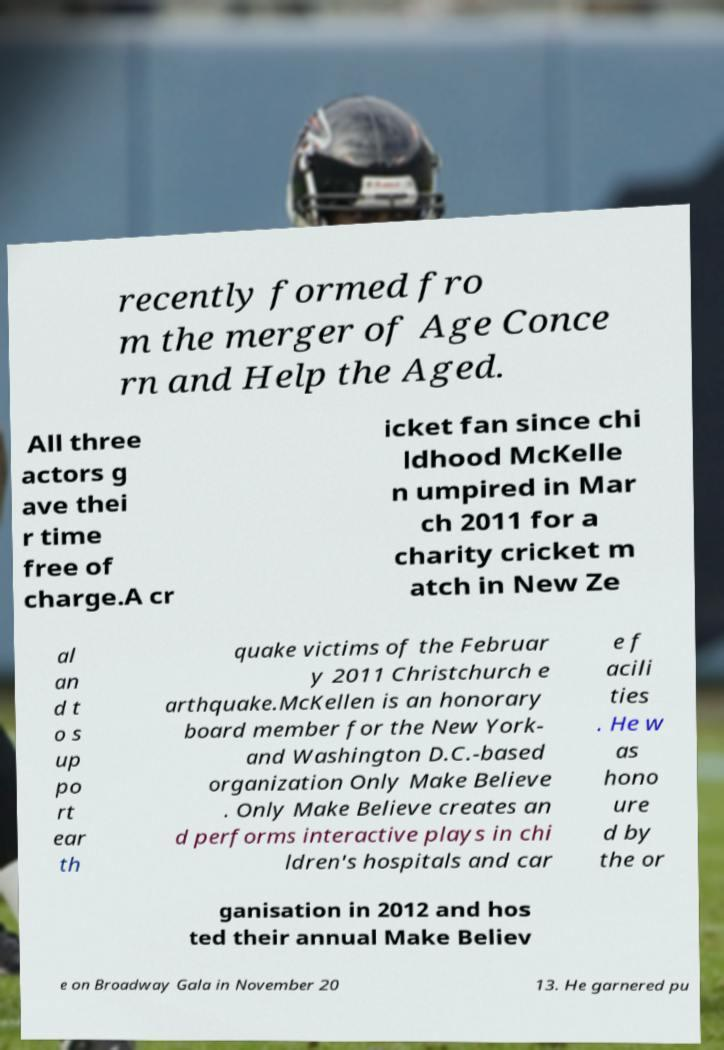For documentation purposes, I need the text within this image transcribed. Could you provide that? recently formed fro m the merger of Age Conce rn and Help the Aged. All three actors g ave thei r time free of charge.A cr icket fan since chi ldhood McKelle n umpired in Mar ch 2011 for a charity cricket m atch in New Ze al an d t o s up po rt ear th quake victims of the Februar y 2011 Christchurch e arthquake.McKellen is an honorary board member for the New York- and Washington D.C.-based organization Only Make Believe . Only Make Believe creates an d performs interactive plays in chi ldren's hospitals and car e f acili ties . He w as hono ure d by the or ganisation in 2012 and hos ted their annual Make Believ e on Broadway Gala in November 20 13. He garnered pu 